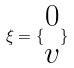<formula> <loc_0><loc_0><loc_500><loc_500>\xi = \{ \begin{matrix} 0 \\ v \end{matrix} \}</formula> 